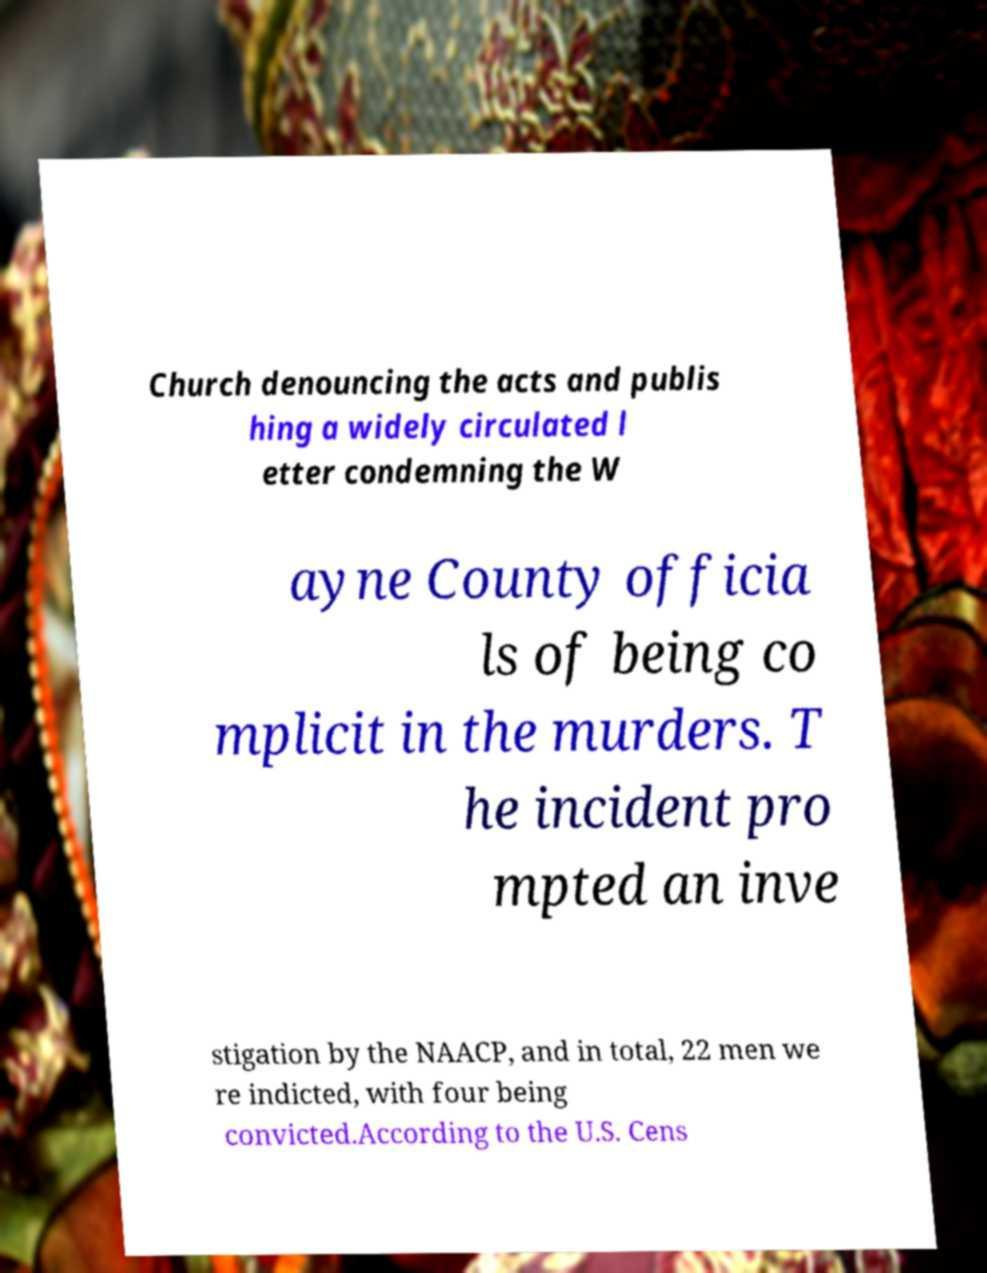Could you assist in decoding the text presented in this image and type it out clearly? Church denouncing the acts and publis hing a widely circulated l etter condemning the W ayne County officia ls of being co mplicit in the murders. T he incident pro mpted an inve stigation by the NAACP, and in total, 22 men we re indicted, with four being convicted.According to the U.S. Cens 